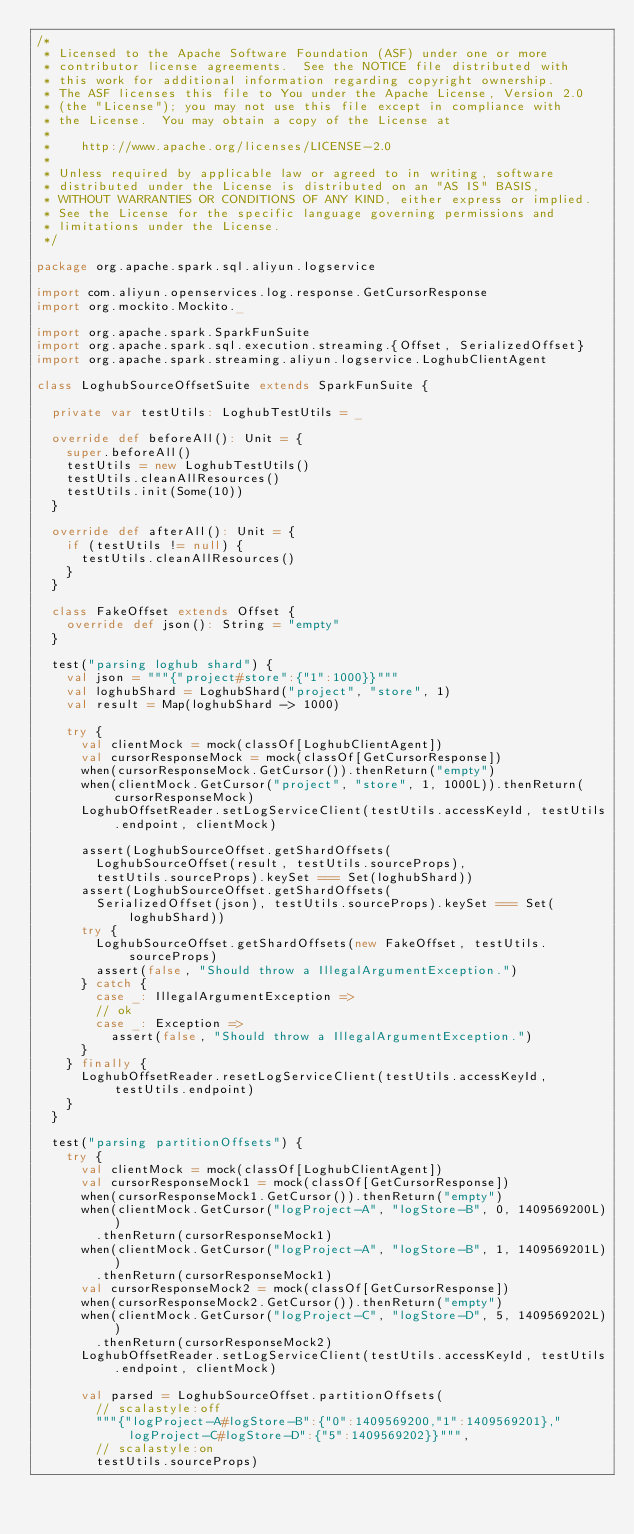<code> <loc_0><loc_0><loc_500><loc_500><_Scala_>/*
 * Licensed to the Apache Software Foundation (ASF) under one or more
 * contributor license agreements.  See the NOTICE file distributed with
 * this work for additional information regarding copyright ownership.
 * The ASF licenses this file to You under the Apache License, Version 2.0
 * (the "License"); you may not use this file except in compliance with
 * the License.  You may obtain a copy of the License at
 *
 *    http://www.apache.org/licenses/LICENSE-2.0
 *
 * Unless required by applicable law or agreed to in writing, software
 * distributed under the License is distributed on an "AS IS" BASIS,
 * WITHOUT WARRANTIES OR CONDITIONS OF ANY KIND, either express or implied.
 * See the License for the specific language governing permissions and
 * limitations under the License.
 */

package org.apache.spark.sql.aliyun.logservice

import com.aliyun.openservices.log.response.GetCursorResponse
import org.mockito.Mockito._

import org.apache.spark.SparkFunSuite
import org.apache.spark.sql.execution.streaming.{Offset, SerializedOffset}
import org.apache.spark.streaming.aliyun.logservice.LoghubClientAgent

class LoghubSourceOffsetSuite extends SparkFunSuite {

  private var testUtils: LoghubTestUtils = _

  override def beforeAll(): Unit = {
    super.beforeAll()
    testUtils = new LoghubTestUtils()
    testUtils.cleanAllResources()
    testUtils.init(Some(10))
  }

  override def afterAll(): Unit = {
    if (testUtils != null) {
      testUtils.cleanAllResources()
    }
  }

  class FakeOffset extends Offset {
    override def json(): String = "empty"
  }

  test("parsing loghub shard") {
    val json = """{"project#store":{"1":1000}}"""
    val loghubShard = LoghubShard("project", "store", 1)
    val result = Map(loghubShard -> 1000)

    try {
      val clientMock = mock(classOf[LoghubClientAgent])
      val cursorResponseMock = mock(classOf[GetCursorResponse])
      when(cursorResponseMock.GetCursor()).thenReturn("empty")
      when(clientMock.GetCursor("project", "store", 1, 1000L)).thenReturn(cursorResponseMock)
      LoghubOffsetReader.setLogServiceClient(testUtils.accessKeyId, testUtils.endpoint, clientMock)

      assert(LoghubSourceOffset.getShardOffsets(
        LoghubSourceOffset(result, testUtils.sourceProps),
        testUtils.sourceProps).keySet === Set(loghubShard))
      assert(LoghubSourceOffset.getShardOffsets(
        SerializedOffset(json), testUtils.sourceProps).keySet === Set(loghubShard))
      try {
        LoghubSourceOffset.getShardOffsets(new FakeOffset, testUtils.sourceProps)
        assert(false, "Should throw a IllegalArgumentException.")
      } catch {
        case _: IllegalArgumentException =>
        // ok
        case _: Exception =>
          assert(false, "Should throw a IllegalArgumentException.")
      }
    } finally {
      LoghubOffsetReader.resetLogServiceClient(testUtils.accessKeyId, testUtils.endpoint)
    }
  }

  test("parsing partitionOffsets") {
    try {
      val clientMock = mock(classOf[LoghubClientAgent])
      val cursorResponseMock1 = mock(classOf[GetCursorResponse])
      when(cursorResponseMock1.GetCursor()).thenReturn("empty")
      when(clientMock.GetCursor("logProject-A", "logStore-B", 0, 1409569200L))
        .thenReturn(cursorResponseMock1)
      when(clientMock.GetCursor("logProject-A", "logStore-B", 1, 1409569201L))
        .thenReturn(cursorResponseMock1)
      val cursorResponseMock2 = mock(classOf[GetCursorResponse])
      when(cursorResponseMock2.GetCursor()).thenReturn("empty")
      when(clientMock.GetCursor("logProject-C", "logStore-D", 5, 1409569202L))
        .thenReturn(cursorResponseMock2)
      LoghubOffsetReader.setLogServiceClient(testUtils.accessKeyId, testUtils.endpoint, clientMock)

      val parsed = LoghubSourceOffset.partitionOffsets(
        // scalastyle:off
        """{"logProject-A#logStore-B":{"0":1409569200,"1":1409569201},"logProject-C#logStore-D":{"5":1409569202}}""",
        // scalastyle:on
        testUtils.sourceProps)</code> 